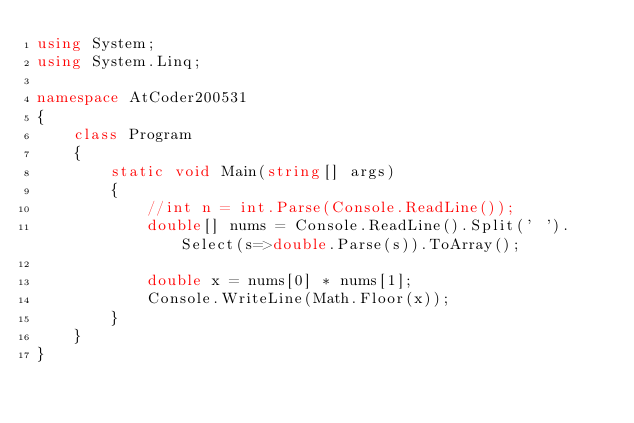Convert code to text. <code><loc_0><loc_0><loc_500><loc_500><_C#_>using System;
using System.Linq;

namespace AtCoder200531
{
    class Program
    {
        static void Main(string[] args)
        {
            //int n = int.Parse(Console.ReadLine());
            double[] nums = Console.ReadLine().Split(' ').Select(s=>double.Parse(s)).ToArray();

            double x = nums[0] * nums[1];
            Console.WriteLine(Math.Floor(x));
        }
    }
}
</code> 